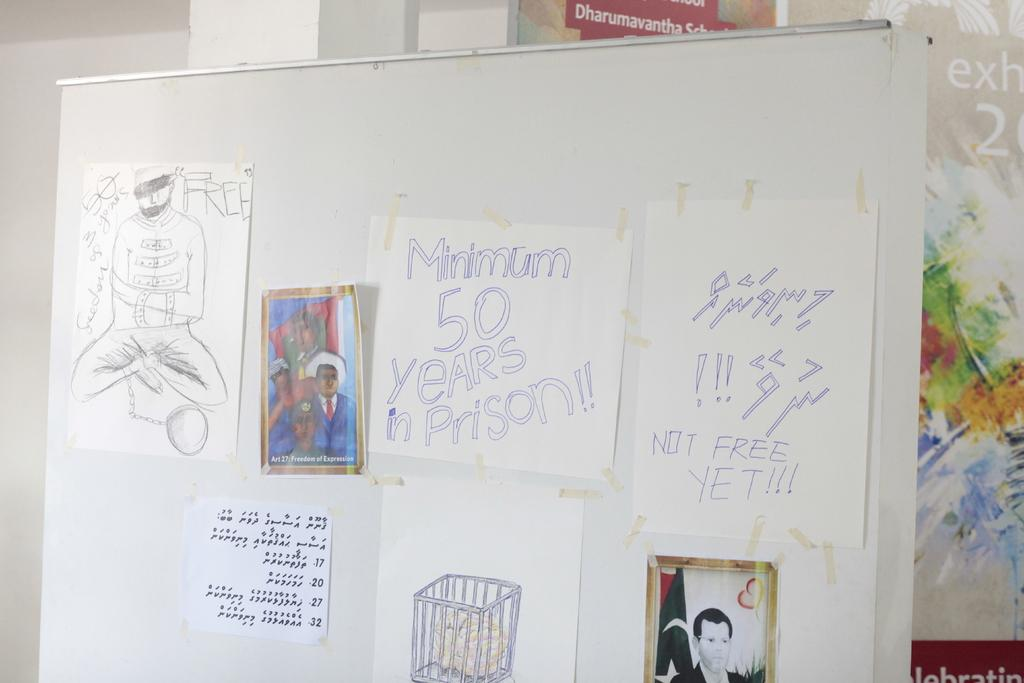<image>
Render a clear and concise summary of the photo. board that has drawings taped to it along with paper that has minimum 50 years in prison on it 